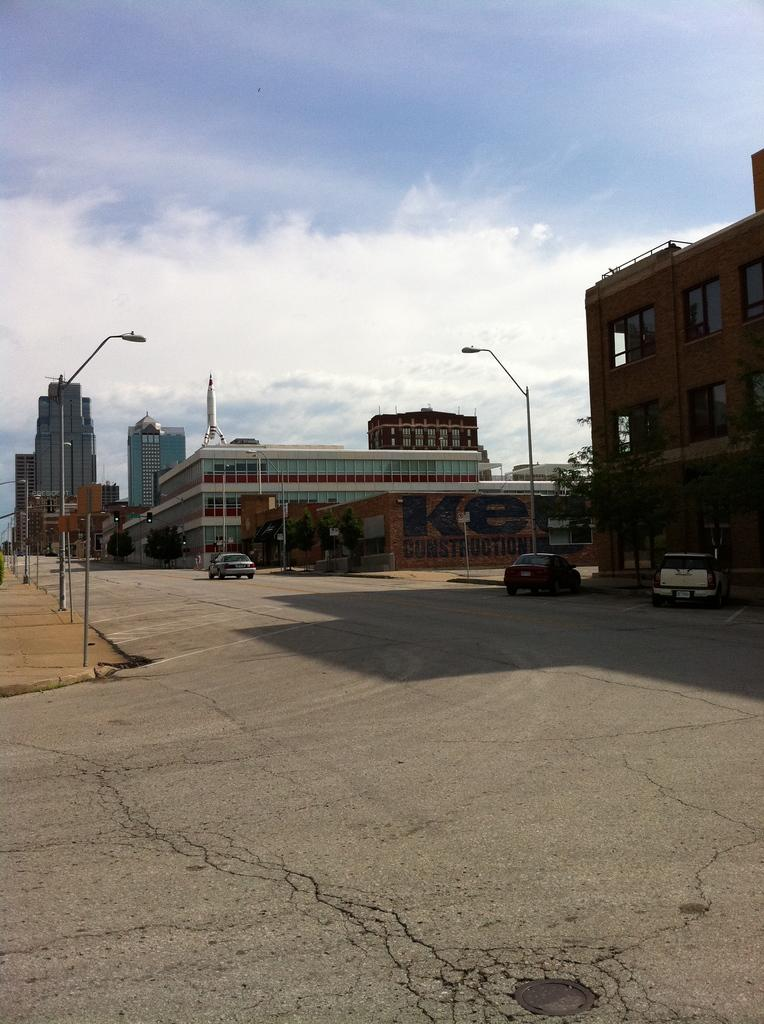What can be seen in the background of the image? There are buildings and poles in the background of the image. What is happening on the road in the image? There are cars on the road in the image. How would you describe the sky in the image? The sky is cloudy in the image. What type of effect does the wrench have on the branch in the image? There is no wrench or branch present in the image. 